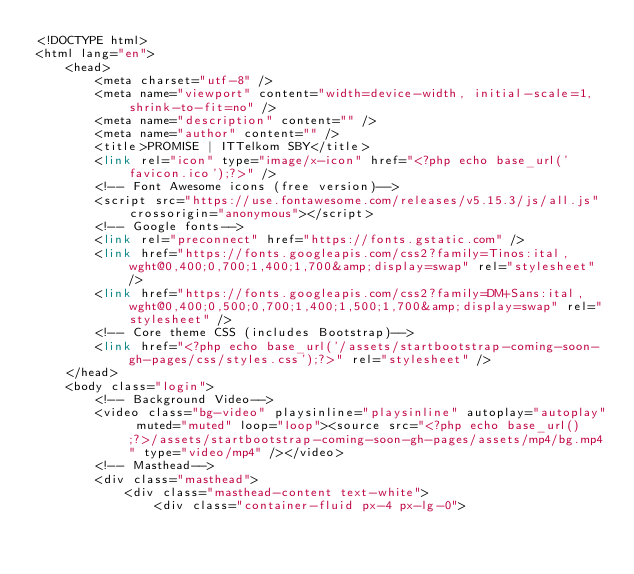Convert code to text. <code><loc_0><loc_0><loc_500><loc_500><_PHP_><!DOCTYPE html>
<html lang="en">
    <head>
        <meta charset="utf-8" />
        <meta name="viewport" content="width=device-width, initial-scale=1, shrink-to-fit=no" />
        <meta name="description" content="" />
        <meta name="author" content="" />
        <title>PROMISE | ITTelkom SBY</title>
        <link rel="icon" type="image/x-icon" href="<?php echo base_url('favicon.ico');?>" />
        <!-- Font Awesome icons (free version)-->
        <script src="https://use.fontawesome.com/releases/v5.15.3/js/all.js" crossorigin="anonymous"></script>
        <!-- Google fonts-->
        <link rel="preconnect" href="https://fonts.gstatic.com" />
        <link href="https://fonts.googleapis.com/css2?family=Tinos:ital,wght@0,400;0,700;1,400;1,700&amp;display=swap" rel="stylesheet" />
        <link href="https://fonts.googleapis.com/css2?family=DM+Sans:ital,wght@0,400;0,500;0,700;1,400;1,500;1,700&amp;display=swap" rel="stylesheet" />
        <!-- Core theme CSS (includes Bootstrap)-->
        <link href="<?php echo base_url('/assets/startbootstrap-coming-soon-gh-pages/css/styles.css');?>" rel="stylesheet" />
    </head>
    <body class="login">
        <!-- Background Video-->
        <video class="bg-video" playsinline="playsinline" autoplay="autoplay" muted="muted" loop="loop"><source src="<?php echo base_url();?>/assets/startbootstrap-coming-soon-gh-pages/assets/mp4/bg.mp4" type="video/mp4" /></video>
        <!-- Masthead-->
        <div class="masthead">
            <div class="masthead-content text-white">
                <div class="container-fluid px-4 px-lg-0"></code> 